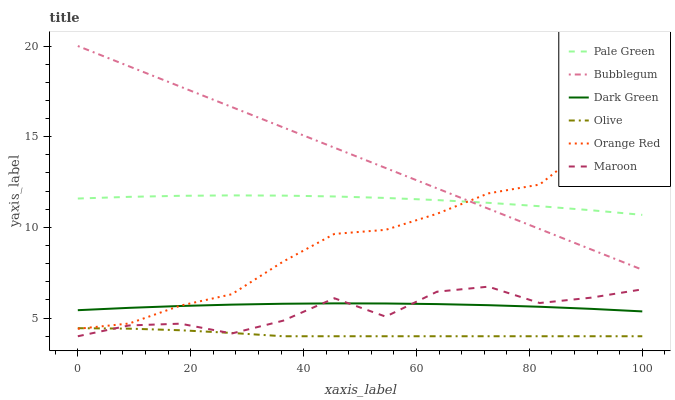Does Olive have the minimum area under the curve?
Answer yes or no. Yes. Does Bubblegum have the maximum area under the curve?
Answer yes or no. Yes. Does Pale Green have the minimum area under the curve?
Answer yes or no. No. Does Pale Green have the maximum area under the curve?
Answer yes or no. No. Is Bubblegum the smoothest?
Answer yes or no. Yes. Is Maroon the roughest?
Answer yes or no. Yes. Is Pale Green the smoothest?
Answer yes or no. No. Is Pale Green the roughest?
Answer yes or no. No. Does Maroon have the lowest value?
Answer yes or no. Yes. Does Bubblegum have the lowest value?
Answer yes or no. No. Does Bubblegum have the highest value?
Answer yes or no. Yes. Does Pale Green have the highest value?
Answer yes or no. No. Is Olive less than Dark Green?
Answer yes or no. Yes. Is Pale Green greater than Dark Green?
Answer yes or no. Yes. Does Orange Red intersect Bubblegum?
Answer yes or no. Yes. Is Orange Red less than Bubblegum?
Answer yes or no. No. Is Orange Red greater than Bubblegum?
Answer yes or no. No. Does Olive intersect Dark Green?
Answer yes or no. No. 